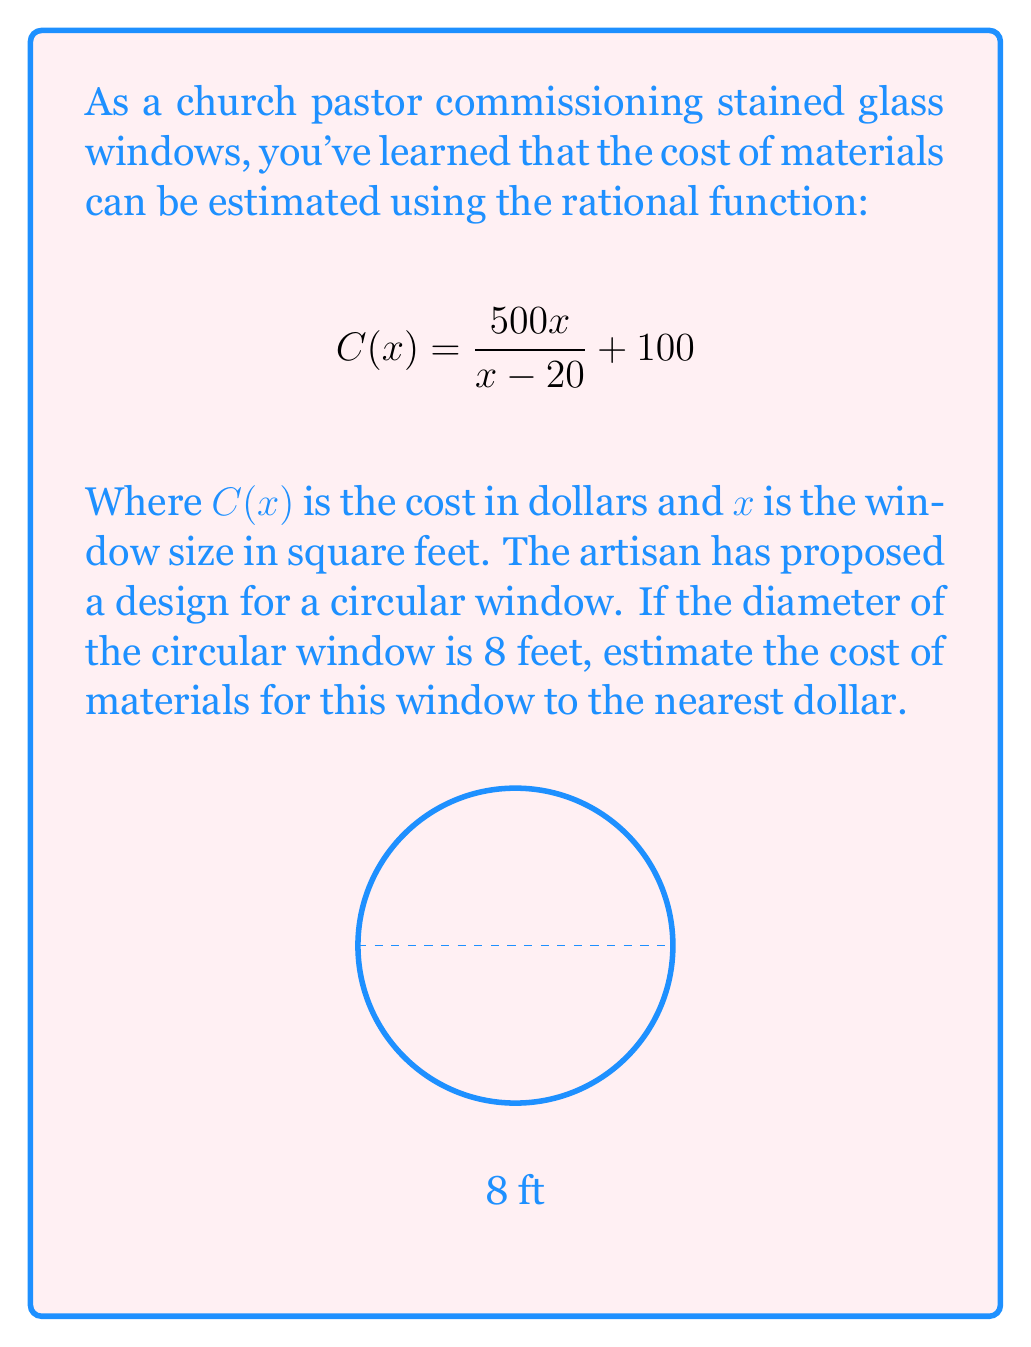Could you help me with this problem? Let's approach this step-by-step:

1) First, we need to calculate the area of the circular window. The formula for the area of a circle is $A = \pi r^2$, where $r$ is the radius.

2) The diameter is 8 feet, so the radius is 4 feet.

3) Calculate the area:
   $A = \pi (4)^2 = 16\pi \approx 50.27$ square feet

4) Now we can use this value in our rational function. Let $x = 50.27$:

   $$C(50.27) = \frac{500(50.27)}{50.27 - 20} + 100$$

5) Simplify:
   $$C(50.27) = \frac{25135}{30.27} + 100$$

6) Evaluate:
   $$C(50.27) \approx 830.36 + 100 = 930.36$$

7) Rounding to the nearest dollar:
   $C(50.27) \approx 930$ dollars
Answer: $930 